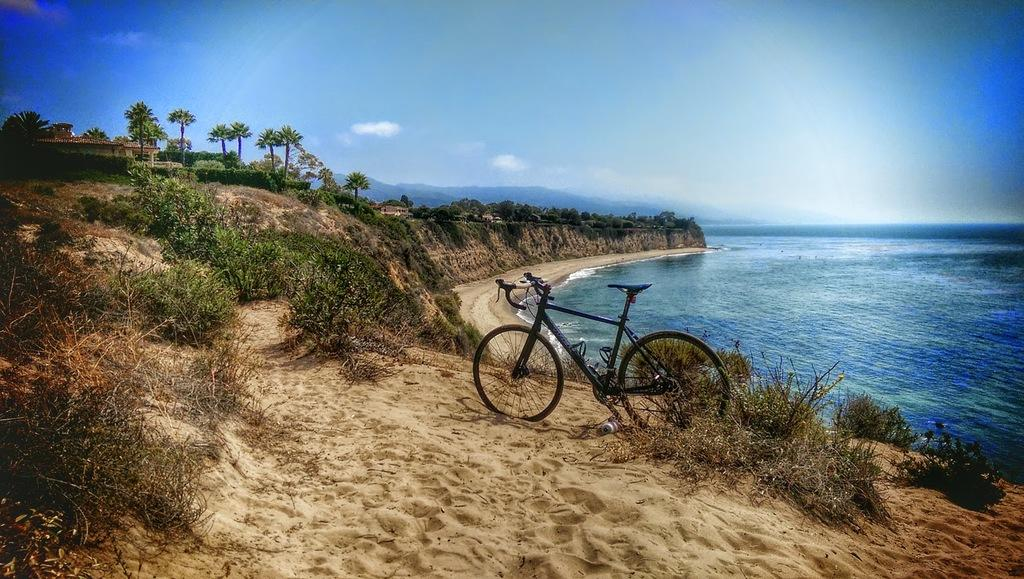What is the main subject in the center of the image? There is a cycle in the center of the image. Where is the cycle located? The cycle is on the sand. What can be seen in the background of the image? There are trees, houses, plants, sand, water, hills, and the sky visible in the background of the image. What is the condition of the sky in the image? The sky is visible in the background of the image, and there are clouds present. What type of art can be seen on the cycle in the image? There is no art visible on the cycle in the image. Is there a boat in the water visible in the background of the image? There is no boat present in the image; only a cycle, sand, and various background elements are visible. 